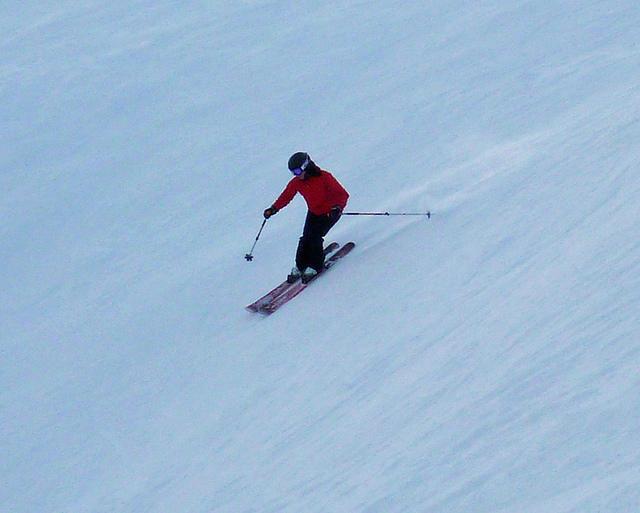Is the person running?
Give a very brief answer. No. Is it cold?
Write a very short answer. Yes. Is the skier good?
Keep it brief. Yes. Is this a routine pose for this activity?
Be succinct. Yes. How is the skier going to get out of this situation?
Keep it brief. Keep going. What is the man doing?
Answer briefly. Skiing. Is the skier on the snow?
Be succinct. Yes. How many skiers are there?
Concise answer only. 1. Did this man wipe out on his skis?
Concise answer only. No. 